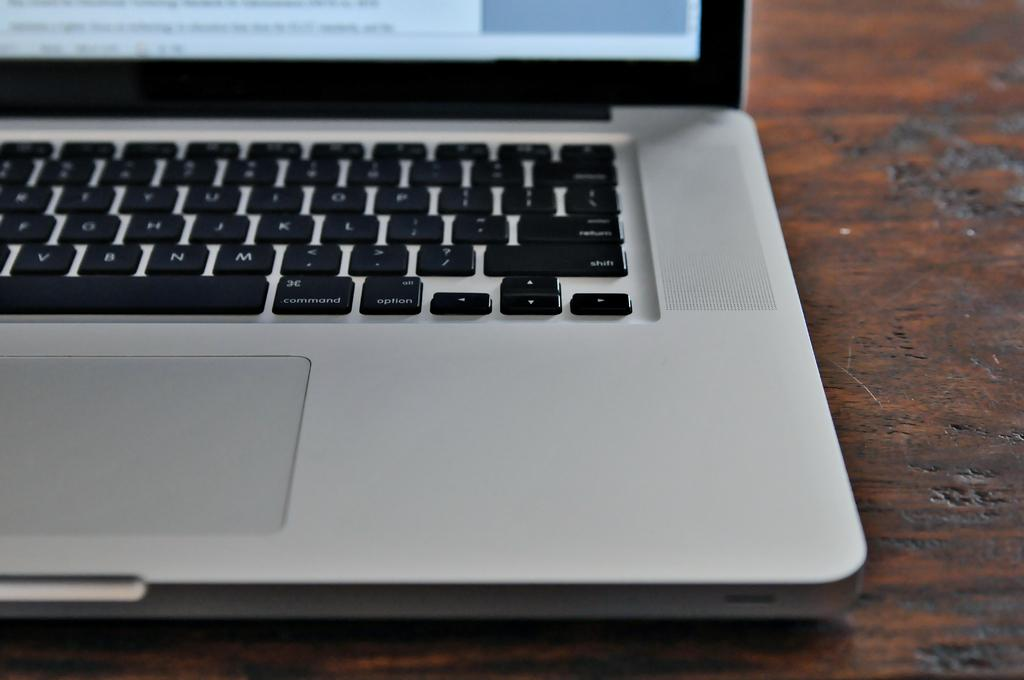What electronic device is visible in the image? There is a laptop in the image. How many bits of information can be found in the image? There is no specific information about bits of data in the image; it simply shows a laptop. What historical discovery is depicted in the image? There is no historical discovery depicted in the image; it only shows a laptop. 